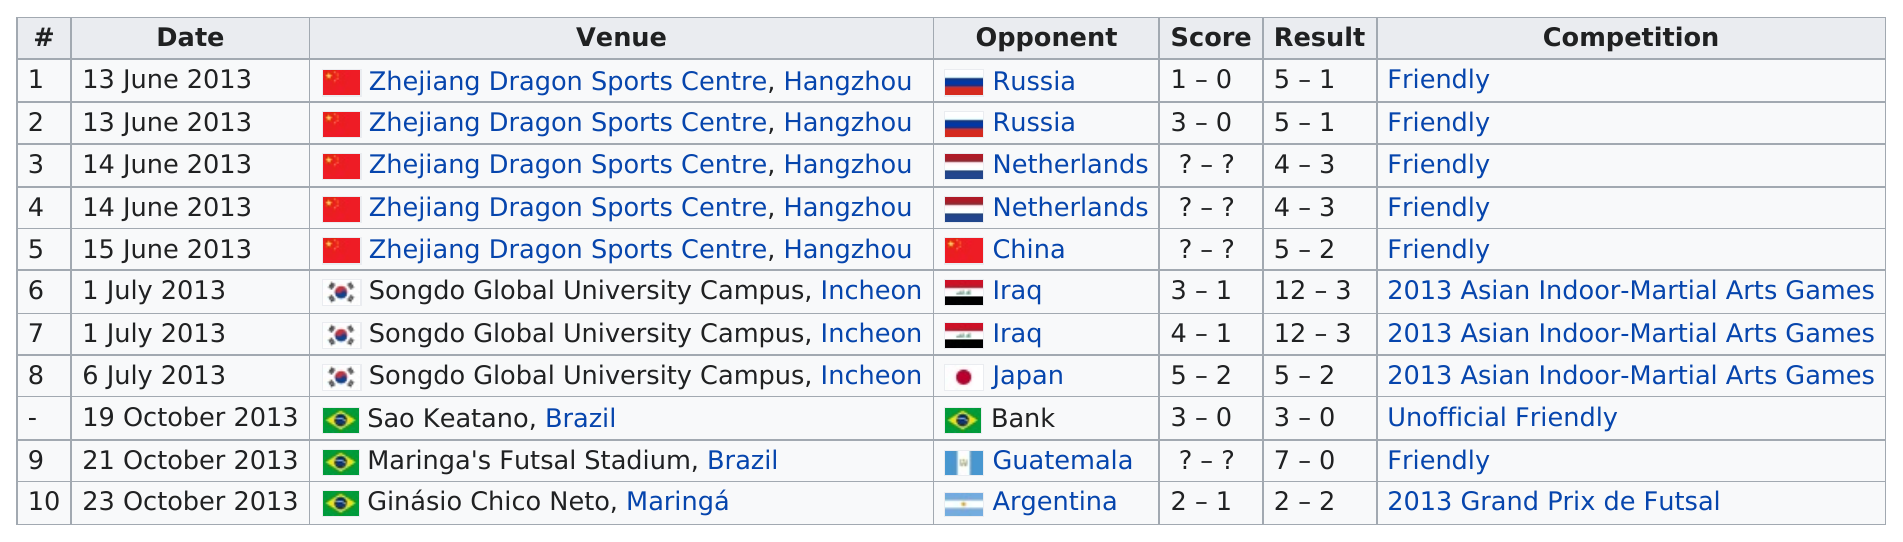Draw attention to some important aspects in this diagram. The last date is October 23, 2013. The venue is located in Brazil three times. Russia is the first opponent listed on this chart. The Maringá's Futsal Stadium in Brazil was previously known as the venue for Ginásio Chico Neto. Japan is followed by Bank, the opponent in this context. 